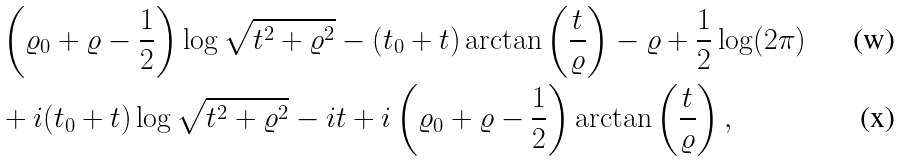<formula> <loc_0><loc_0><loc_500><loc_500>& \left ( \varrho _ { 0 } + \varrho - \frac { 1 } { 2 } \right ) \log \sqrt { t ^ { 2 } + \varrho ^ { 2 } } - ( t _ { 0 } + t ) \arctan \left ( \frac { t } { \varrho } \right ) - \varrho + \frac { 1 } { 2 } \log ( 2 \pi ) \\ & + i ( t _ { 0 } + t ) \log { \sqrt { t ^ { 2 } + \varrho ^ { 2 } } } - i t + i \left ( \varrho _ { 0 } + \varrho - \frac { 1 } { 2 } \right ) \arctan \left ( \frac { t } { \varrho } \right ) ,</formula> 